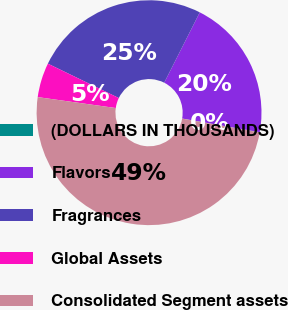Convert chart to OTSL. <chart><loc_0><loc_0><loc_500><loc_500><pie_chart><fcel>(DOLLARS IN THOUSANDS)<fcel>Flavors<fcel>Fragrances<fcel>Global Assets<fcel>Consolidated Segment assets<nl><fcel>0.04%<fcel>20.33%<fcel>25.27%<fcel>4.97%<fcel>49.4%<nl></chart> 